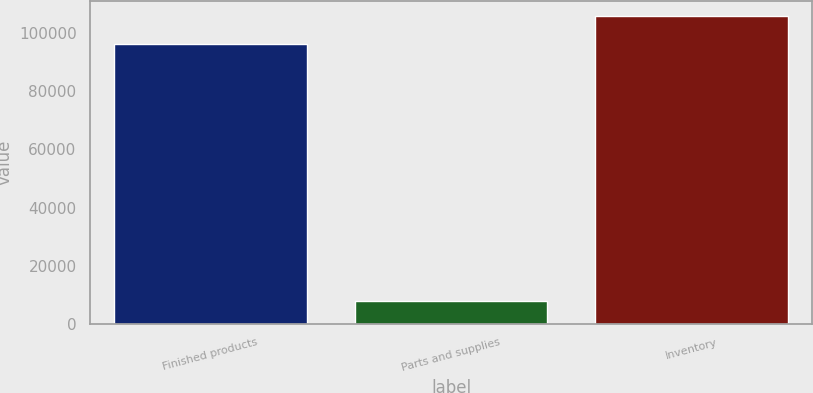Convert chart. <chart><loc_0><loc_0><loc_500><loc_500><bar_chart><fcel>Finished products<fcel>Parts and supplies<fcel>Inventory<nl><fcel>96139<fcel>8096<fcel>105753<nl></chart> 